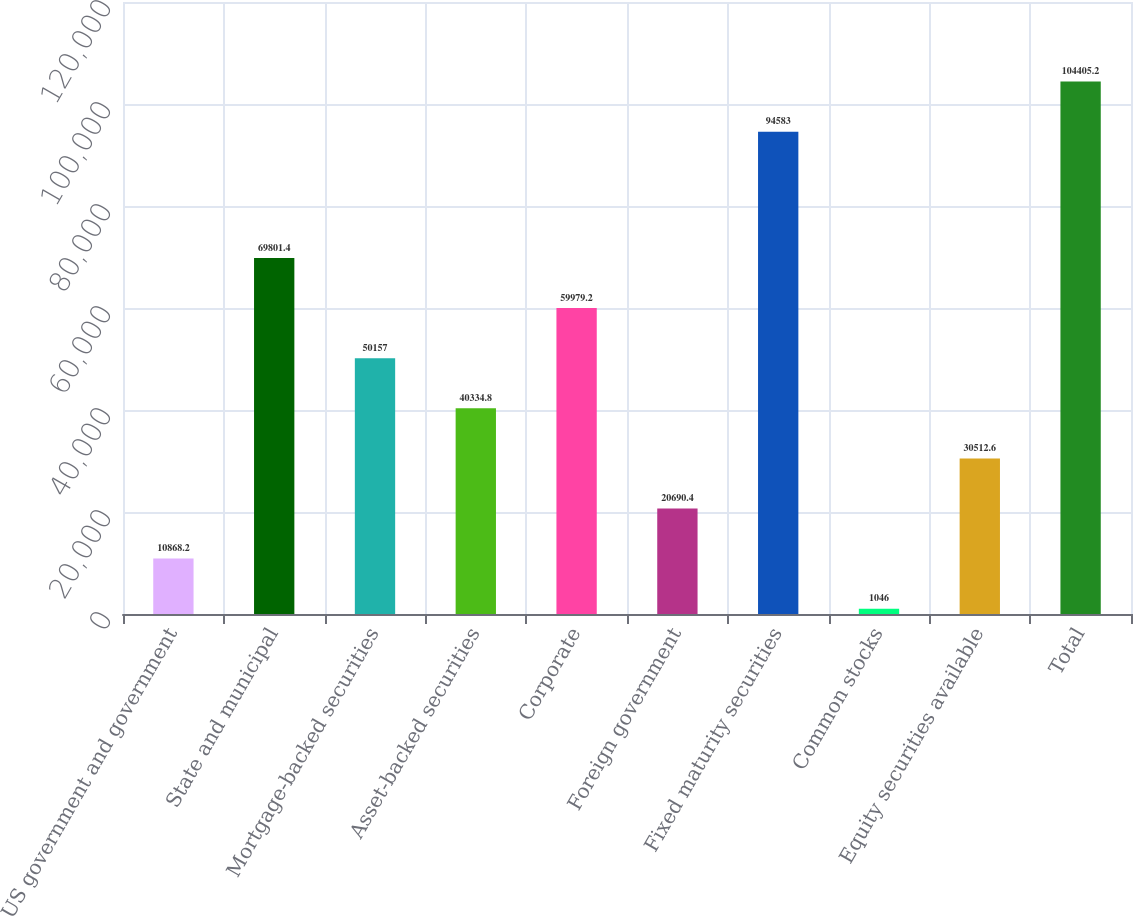Convert chart. <chart><loc_0><loc_0><loc_500><loc_500><bar_chart><fcel>US government and government<fcel>State and municipal<fcel>Mortgage-backed securities<fcel>Asset-backed securities<fcel>Corporate<fcel>Foreign government<fcel>Fixed maturity securities<fcel>Common stocks<fcel>Equity securities available<fcel>Total<nl><fcel>10868.2<fcel>69801.4<fcel>50157<fcel>40334.8<fcel>59979.2<fcel>20690.4<fcel>94583<fcel>1046<fcel>30512.6<fcel>104405<nl></chart> 